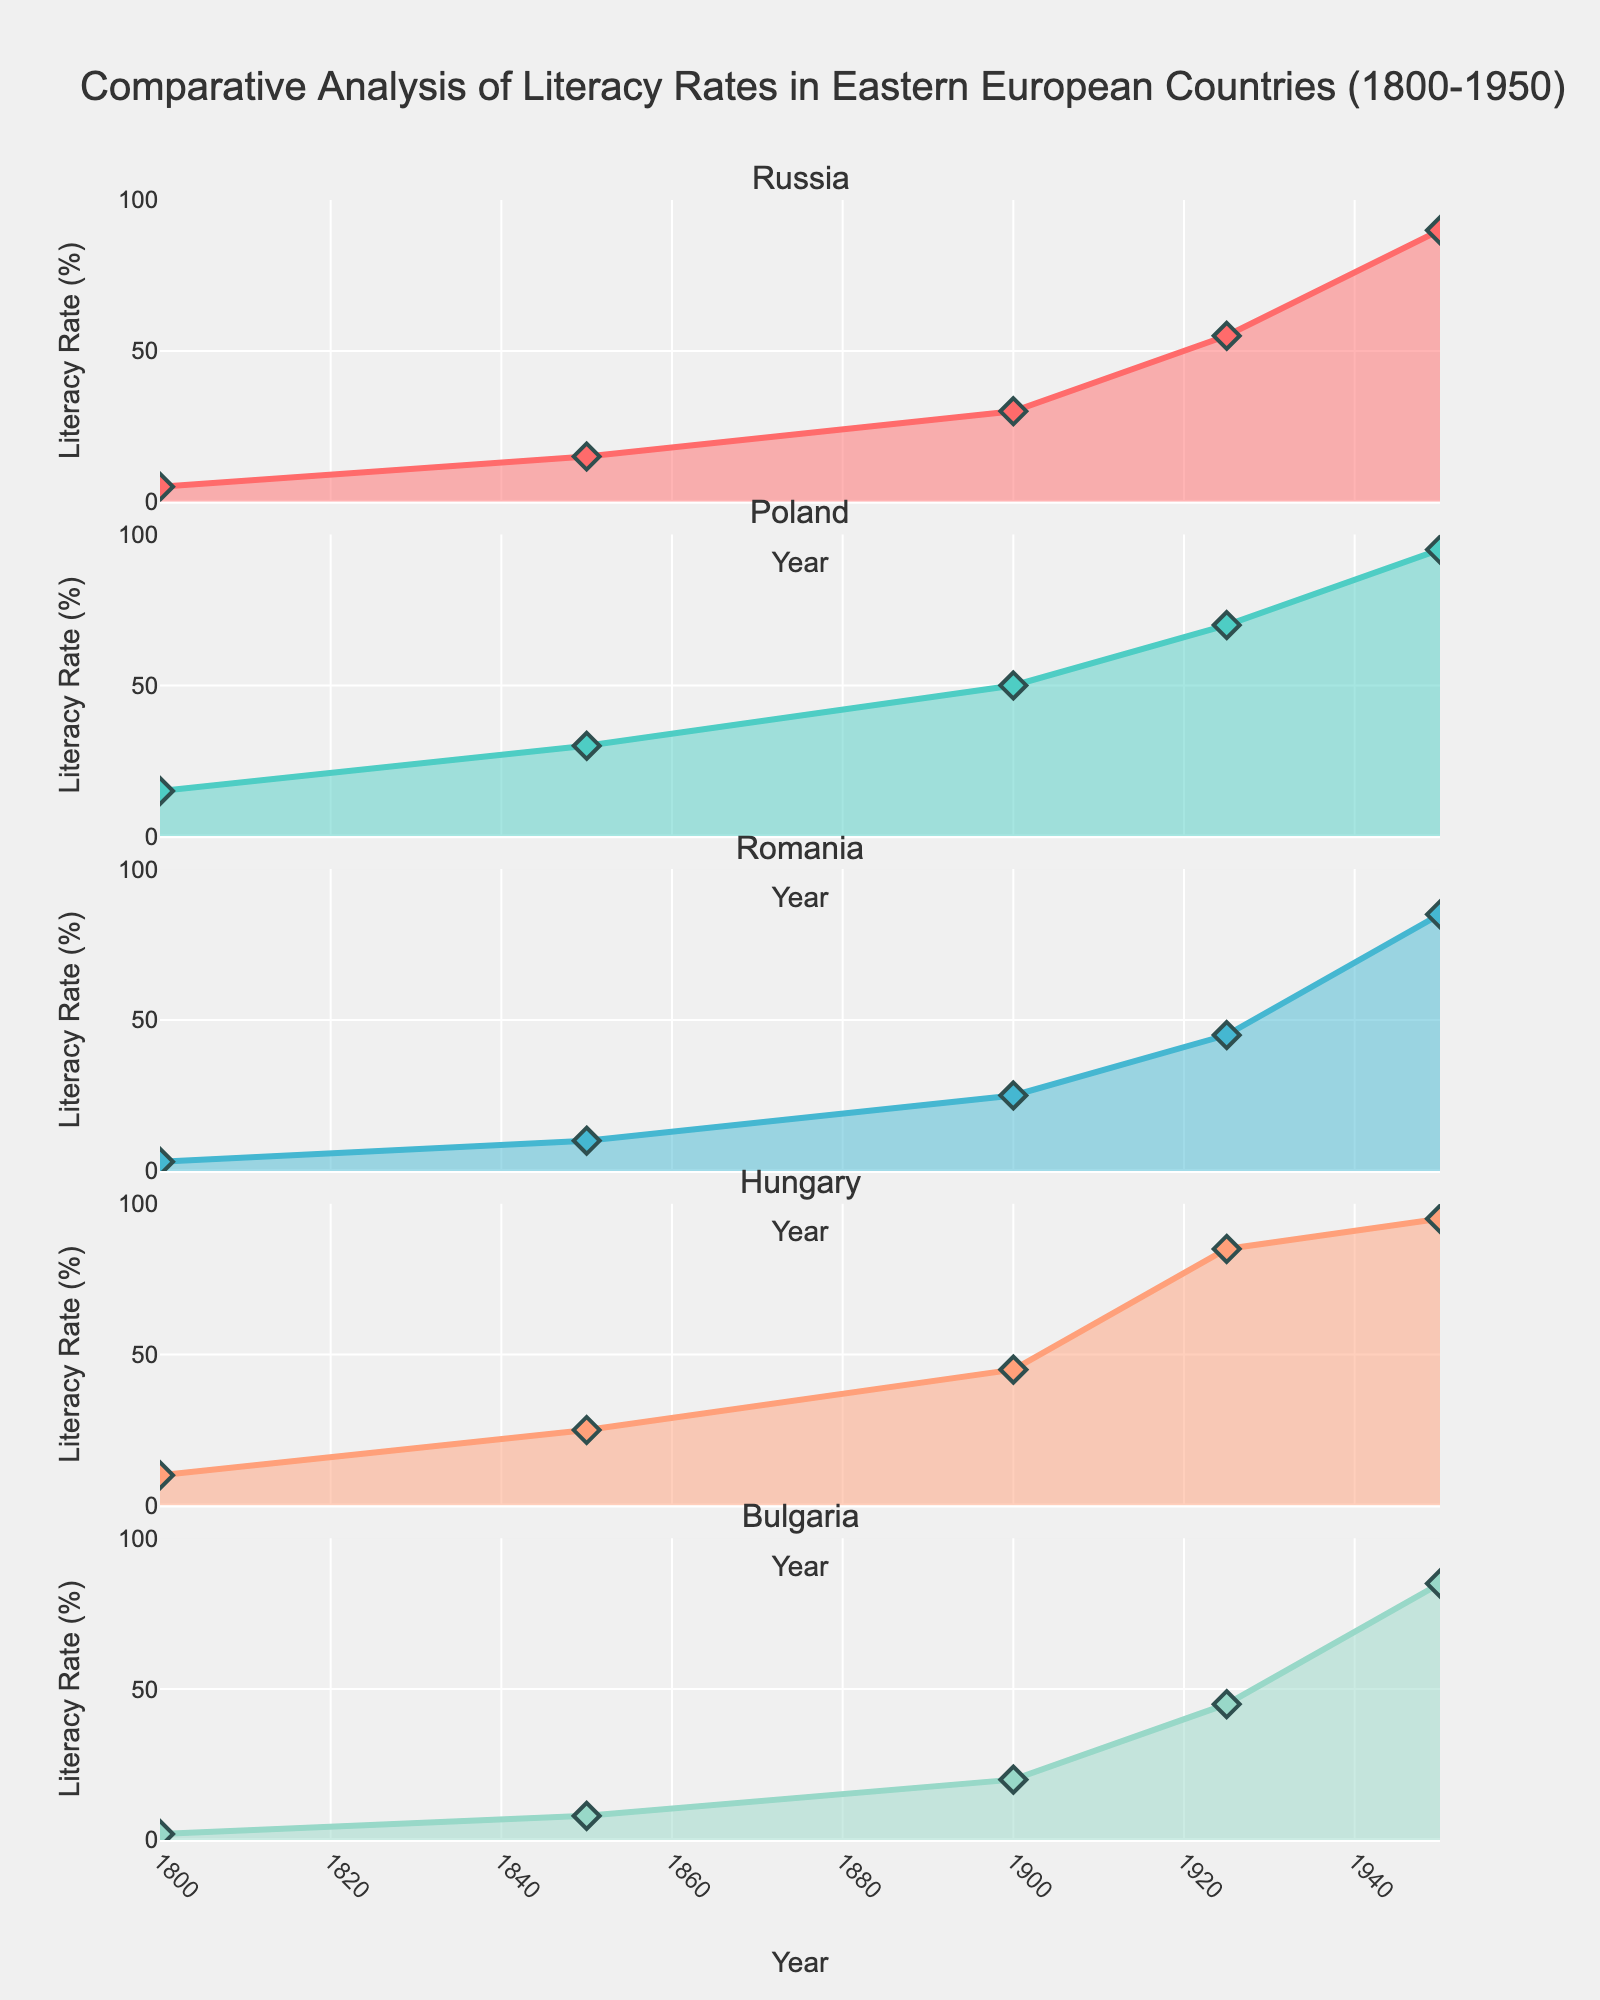What is the title of the entire figure? The title is displayed at the top of the figure.
Answer: Global Skincare Product Analysis Which skin type has the largest market share according to the pie chart? The pie chart on the top right shows the market share for different skin types. The largest section is labeled "Dry".
Answer: Dry How many products are featured in the bar chart on the bottom right for the top products by preference score? The bar chart in the bottom right shows the top products by preference score. Counting the bars will give the number of products.
Answer: 5 What is the preference score for the product with the highest preference score in South America? On the bar chart on the top left, locate the South America products and find the highest preference score value. The product 'Sunscreen' has the highest bar in the South America section.
Answer: 8.8 For the scatter plot, which product has both a high preference score and high market share? Locate the data points in the scatter plot on the bottom left, and find the one with both high x (preference score) and y (market share %) values. The product 'Sheet Mask' stands out.
Answer: Sheet Mask Which region has the product with the highest overall preference score? In the bar chart on the top left, find the product with the highest bar overall and identify its region. The product is 'Sheet Mask' in Asia.
Answer: Asia Between 'Shea Butter' and 'Aloe Vera Gel', which product has a higher preference score and by how much? Compare the bars for 'Shea Butter' and 'Aloe Vera Gel' in the respective regions (Africa and South America) in the top left chart. 'Shea Butter' has a preference score of 9.0, and 'Aloe Vera Gel' is 8.2. Subtract the values to find the difference.
Answer: 0.8 Which region has the most diverse range of product preferences shown in the figure? Diversity can be deduced by examining the top left bar chart and observing the number of different product types within each region. Asia displays three distinct products: Clay Mask, Sheet Mask, and Essence.
Answer: Asia What is the correlation between preference score and market share based on the scatter plot? Examine the trend of data points in the scatter plot (bottom left). The scatter plot shows that data points are spread out without a clear linear pattern, suggesting a weak correlation.
Answer: Weak correlation Which skin type contributes the least to the total market share? Refer to the pie chart (top right) and identify the smallest segment by color/label.
Answer: Combination 